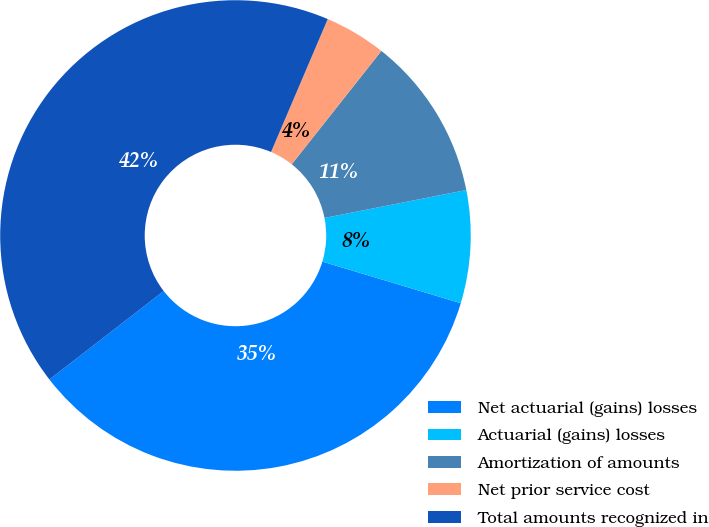Convert chart to OTSL. <chart><loc_0><loc_0><loc_500><loc_500><pie_chart><fcel>Net actuarial (gains) losses<fcel>Actuarial (gains) losses<fcel>Amortization of amounts<fcel>Net prior service cost<fcel>Total amounts recognized in<nl><fcel>34.87%<fcel>7.74%<fcel>11.26%<fcel>4.23%<fcel>41.9%<nl></chart> 